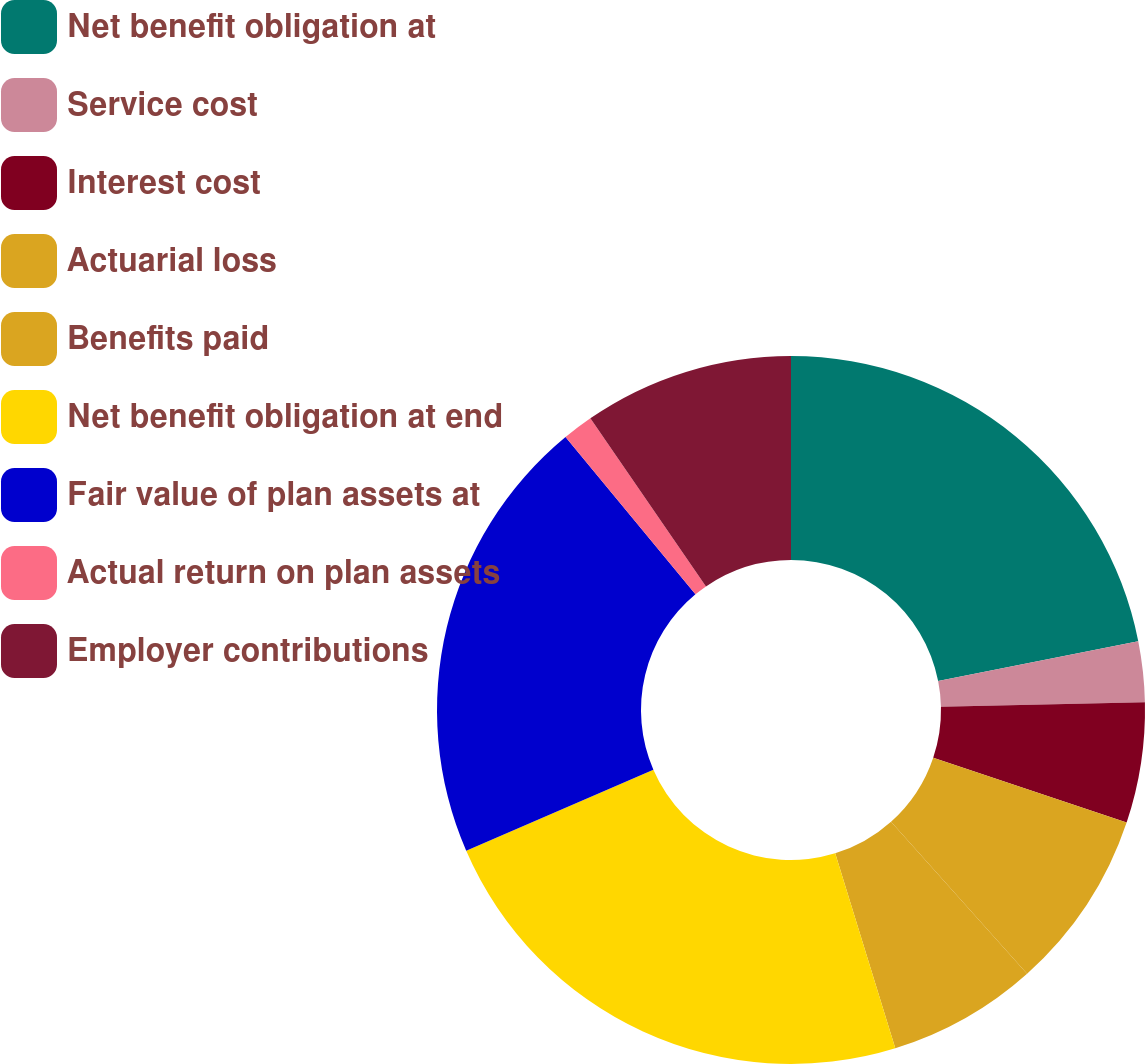Convert chart to OTSL. <chart><loc_0><loc_0><loc_500><loc_500><pie_chart><fcel>Net benefit obligation at<fcel>Service cost<fcel>Interest cost<fcel>Actuarial loss<fcel>Benefits paid<fcel>Net benefit obligation at end<fcel>Fair value of plan assets at<fcel>Actual return on plan assets<fcel>Employer contributions<nl><fcel>21.89%<fcel>2.76%<fcel>5.5%<fcel>8.23%<fcel>6.86%<fcel>23.25%<fcel>20.52%<fcel>1.4%<fcel>9.59%<nl></chart> 